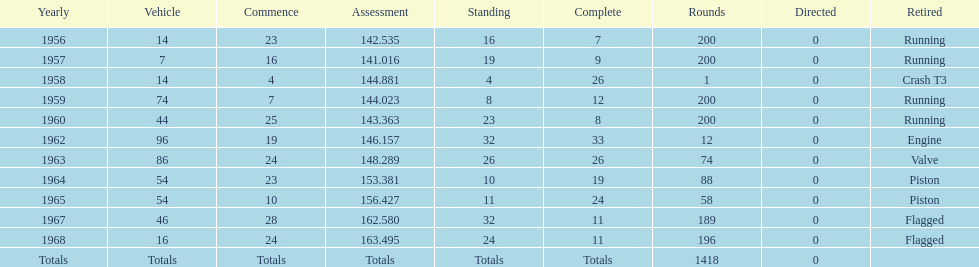What was its best starting position? 4. 